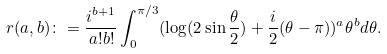<formula> <loc_0><loc_0><loc_500><loc_500>r ( a , b ) \colon = \frac { i ^ { b + 1 } } { a ! b ! } \int _ { 0 } ^ { \pi / 3 } ( \log ( 2 \sin \frac { \theta } { 2 } ) + \frac { i } { 2 } ( \theta - \pi ) ) ^ { a } \theta ^ { b } d \theta .</formula> 